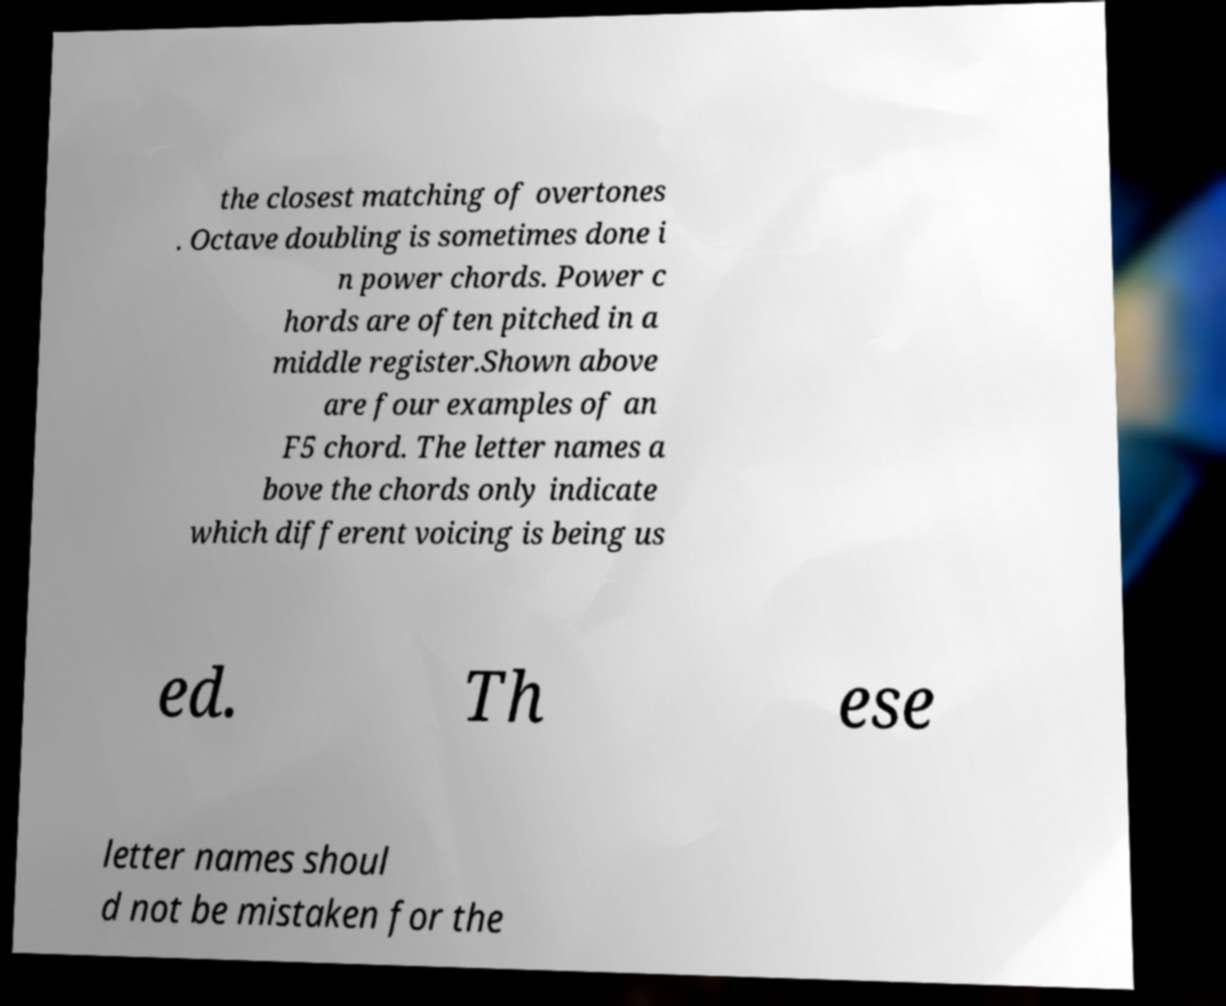I need the written content from this picture converted into text. Can you do that? the closest matching of overtones . Octave doubling is sometimes done i n power chords. Power c hords are often pitched in a middle register.Shown above are four examples of an F5 chord. The letter names a bove the chords only indicate which different voicing is being us ed. Th ese letter names shoul d not be mistaken for the 